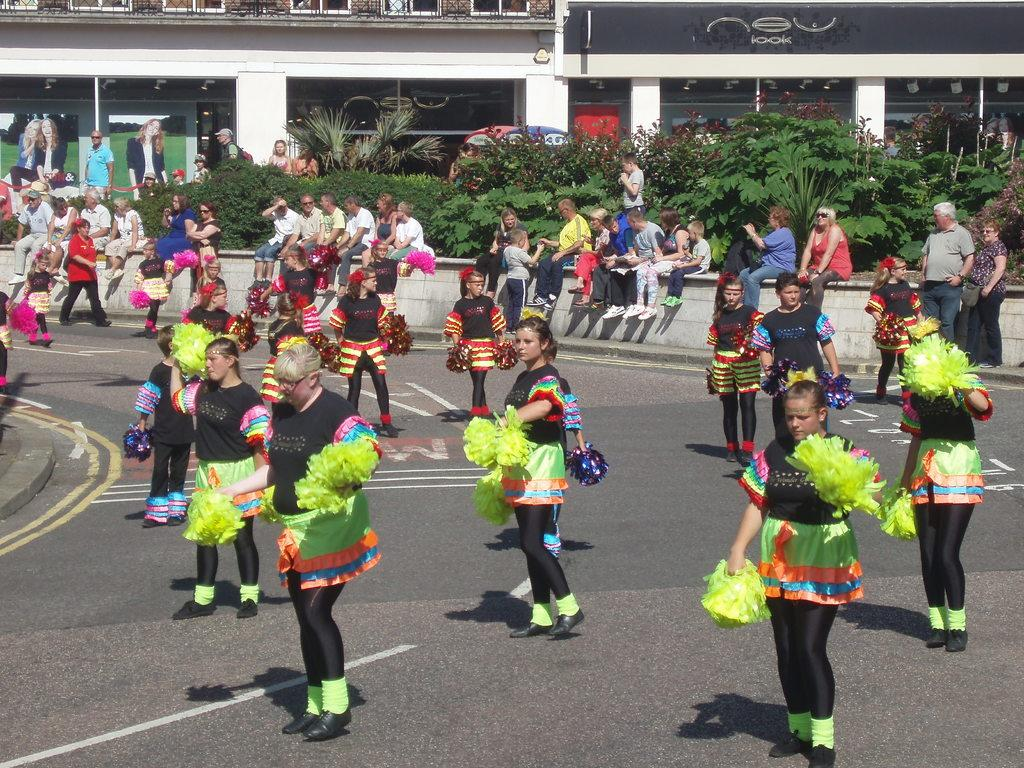What are the people in the front of the image doing? The people in the front of the image are dancing. What can be seen in the background of the image? There are trees and buildings in the background of the image. How many people are visible in the image? There are people scattered throughout the image. What scientific experiment is being conducted in the image? There is no scientific experiment present in the image; it features people dancing in the front and trees and buildings in the background. Can you tell me how many animals are visible in the zoo in the image? There is no zoo present in the image, so it is not possible to determine the number of animals visible. 